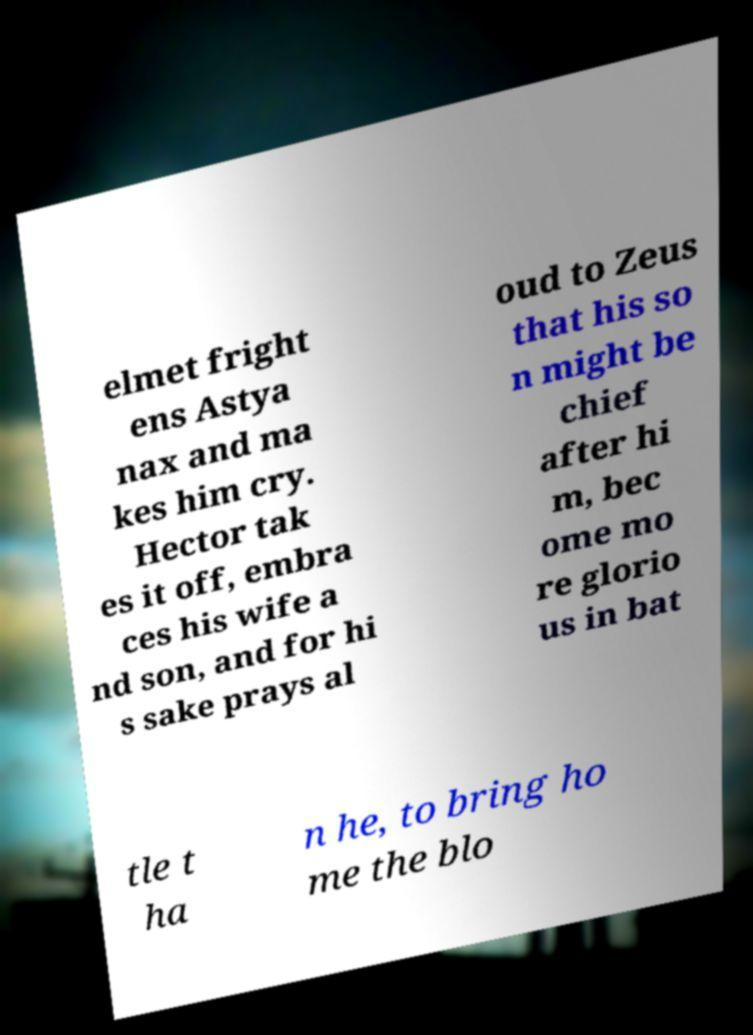There's text embedded in this image that I need extracted. Can you transcribe it verbatim? elmet fright ens Astya nax and ma kes him cry. Hector tak es it off, embra ces his wife a nd son, and for hi s sake prays al oud to Zeus that his so n might be chief after hi m, bec ome mo re glorio us in bat tle t ha n he, to bring ho me the blo 